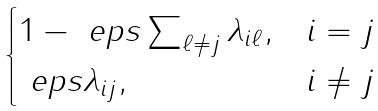Convert formula to latex. <formula><loc_0><loc_0><loc_500><loc_500>\begin{cases} 1 - \ e p s \sum _ { \ell \ne j } \lambda _ { i \ell } , & i = j \\ \ e p s \lambda _ { i j } , & i \ne j \end{cases}</formula> 